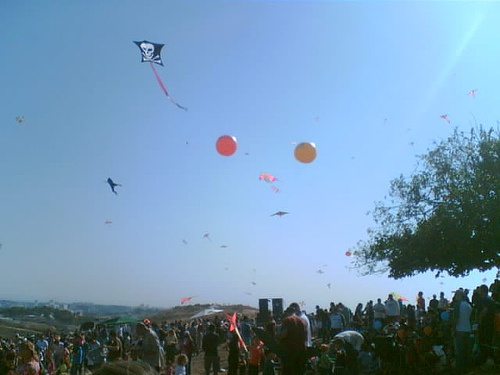Describe the objects in this image and their specific colors. I can see kite in gray, lightblue, and darkgray tones, people in gray, black, blue, and lightblue tones, people in gray, black, and maroon tones, people in gray, black, and darkgray tones, and people in gray, black, blue, and navy tones in this image. 